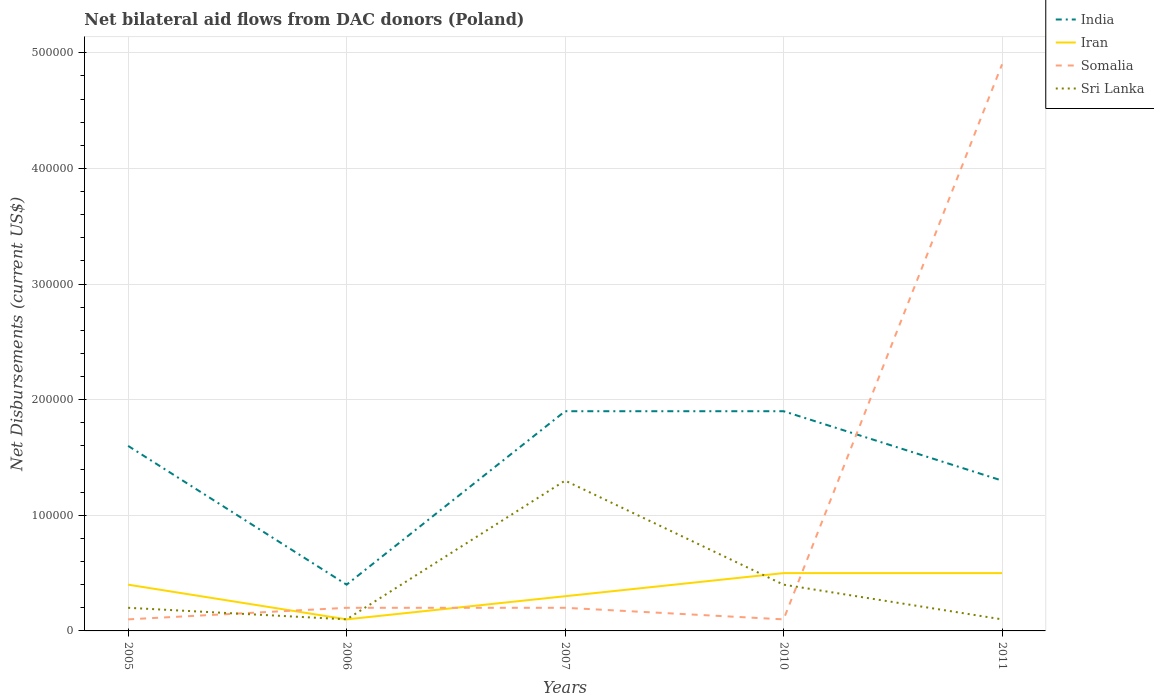How many different coloured lines are there?
Keep it short and to the point. 4. Does the line corresponding to Iran intersect with the line corresponding to India?
Keep it short and to the point. No. Is the number of lines equal to the number of legend labels?
Make the answer very short. Yes. Across all years, what is the maximum net bilateral aid flows in Sri Lanka?
Ensure brevity in your answer.  10000. What is the total net bilateral aid flows in India in the graph?
Give a very brief answer. 6.00e+04. What is the difference between the highest and the second highest net bilateral aid flows in India?
Give a very brief answer. 1.50e+05. What is the difference between the highest and the lowest net bilateral aid flows in Iran?
Give a very brief answer. 3. Where does the legend appear in the graph?
Keep it short and to the point. Top right. How are the legend labels stacked?
Provide a short and direct response. Vertical. What is the title of the graph?
Your response must be concise. Net bilateral aid flows from DAC donors (Poland). Does "Mauritania" appear as one of the legend labels in the graph?
Give a very brief answer. No. What is the label or title of the Y-axis?
Give a very brief answer. Net Disbursements (current US$). What is the Net Disbursements (current US$) of Iran in 2005?
Offer a very short reply. 4.00e+04. What is the Net Disbursements (current US$) of Somalia in 2005?
Offer a terse response. 10000. What is the Net Disbursements (current US$) in Sri Lanka in 2005?
Your answer should be compact. 2.00e+04. What is the Net Disbursements (current US$) in India in 2006?
Make the answer very short. 4.00e+04. What is the Net Disbursements (current US$) of Iran in 2006?
Your answer should be very brief. 10000. What is the Net Disbursements (current US$) in Sri Lanka in 2006?
Give a very brief answer. 10000. What is the Net Disbursements (current US$) of Iran in 2007?
Your answer should be compact. 3.00e+04. What is the Net Disbursements (current US$) in India in 2010?
Your answer should be compact. 1.90e+05. What is the Net Disbursements (current US$) of Somalia in 2010?
Make the answer very short. 10000. What is the Net Disbursements (current US$) of India in 2011?
Offer a very short reply. 1.30e+05. What is the Net Disbursements (current US$) of Somalia in 2011?
Your answer should be compact. 4.90e+05. What is the Net Disbursements (current US$) in Sri Lanka in 2011?
Make the answer very short. 10000. Across all years, what is the maximum Net Disbursements (current US$) in Iran?
Your answer should be very brief. 5.00e+04. Across all years, what is the maximum Net Disbursements (current US$) in Somalia?
Provide a short and direct response. 4.90e+05. Across all years, what is the maximum Net Disbursements (current US$) in Sri Lanka?
Keep it short and to the point. 1.30e+05. Across all years, what is the minimum Net Disbursements (current US$) of Somalia?
Offer a very short reply. 10000. Across all years, what is the minimum Net Disbursements (current US$) in Sri Lanka?
Provide a succinct answer. 10000. What is the total Net Disbursements (current US$) in India in the graph?
Ensure brevity in your answer.  7.10e+05. What is the total Net Disbursements (current US$) in Iran in the graph?
Provide a succinct answer. 1.80e+05. What is the total Net Disbursements (current US$) in Somalia in the graph?
Your answer should be very brief. 5.50e+05. What is the difference between the Net Disbursements (current US$) of Somalia in 2005 and that in 2006?
Your response must be concise. -10000. What is the difference between the Net Disbursements (current US$) in India in 2005 and that in 2007?
Keep it short and to the point. -3.00e+04. What is the difference between the Net Disbursements (current US$) in Somalia in 2005 and that in 2007?
Provide a short and direct response. -10000. What is the difference between the Net Disbursements (current US$) in Sri Lanka in 2005 and that in 2007?
Keep it short and to the point. -1.10e+05. What is the difference between the Net Disbursements (current US$) in India in 2005 and that in 2010?
Ensure brevity in your answer.  -3.00e+04. What is the difference between the Net Disbursements (current US$) of Sri Lanka in 2005 and that in 2010?
Ensure brevity in your answer.  -2.00e+04. What is the difference between the Net Disbursements (current US$) of India in 2005 and that in 2011?
Offer a very short reply. 3.00e+04. What is the difference between the Net Disbursements (current US$) of Iran in 2005 and that in 2011?
Make the answer very short. -10000. What is the difference between the Net Disbursements (current US$) of Somalia in 2005 and that in 2011?
Ensure brevity in your answer.  -4.80e+05. What is the difference between the Net Disbursements (current US$) of Sri Lanka in 2005 and that in 2011?
Your answer should be very brief. 10000. What is the difference between the Net Disbursements (current US$) in India in 2006 and that in 2007?
Your response must be concise. -1.50e+05. What is the difference between the Net Disbursements (current US$) of Sri Lanka in 2006 and that in 2007?
Your answer should be compact. -1.20e+05. What is the difference between the Net Disbursements (current US$) in India in 2006 and that in 2010?
Provide a short and direct response. -1.50e+05. What is the difference between the Net Disbursements (current US$) in Iran in 2006 and that in 2010?
Your answer should be compact. -4.00e+04. What is the difference between the Net Disbursements (current US$) of Somalia in 2006 and that in 2010?
Provide a succinct answer. 10000. What is the difference between the Net Disbursements (current US$) of India in 2006 and that in 2011?
Keep it short and to the point. -9.00e+04. What is the difference between the Net Disbursements (current US$) of Somalia in 2006 and that in 2011?
Offer a very short reply. -4.70e+05. What is the difference between the Net Disbursements (current US$) in India in 2007 and that in 2010?
Provide a succinct answer. 0. What is the difference between the Net Disbursements (current US$) in Iran in 2007 and that in 2010?
Keep it short and to the point. -2.00e+04. What is the difference between the Net Disbursements (current US$) in Somalia in 2007 and that in 2010?
Keep it short and to the point. 10000. What is the difference between the Net Disbursements (current US$) in Sri Lanka in 2007 and that in 2010?
Keep it short and to the point. 9.00e+04. What is the difference between the Net Disbursements (current US$) of India in 2007 and that in 2011?
Give a very brief answer. 6.00e+04. What is the difference between the Net Disbursements (current US$) in Iran in 2007 and that in 2011?
Offer a very short reply. -2.00e+04. What is the difference between the Net Disbursements (current US$) of Somalia in 2007 and that in 2011?
Provide a succinct answer. -4.70e+05. What is the difference between the Net Disbursements (current US$) of Somalia in 2010 and that in 2011?
Ensure brevity in your answer.  -4.80e+05. What is the difference between the Net Disbursements (current US$) of Sri Lanka in 2010 and that in 2011?
Provide a succinct answer. 3.00e+04. What is the difference between the Net Disbursements (current US$) in India in 2005 and the Net Disbursements (current US$) in Iran in 2006?
Provide a succinct answer. 1.50e+05. What is the difference between the Net Disbursements (current US$) in Iran in 2005 and the Net Disbursements (current US$) in Somalia in 2006?
Keep it short and to the point. 2.00e+04. What is the difference between the Net Disbursements (current US$) of India in 2005 and the Net Disbursements (current US$) of Iran in 2007?
Ensure brevity in your answer.  1.30e+05. What is the difference between the Net Disbursements (current US$) in Iran in 2005 and the Net Disbursements (current US$) in Somalia in 2007?
Ensure brevity in your answer.  2.00e+04. What is the difference between the Net Disbursements (current US$) in Iran in 2005 and the Net Disbursements (current US$) in Sri Lanka in 2007?
Provide a succinct answer. -9.00e+04. What is the difference between the Net Disbursements (current US$) in India in 2005 and the Net Disbursements (current US$) in Iran in 2010?
Give a very brief answer. 1.10e+05. What is the difference between the Net Disbursements (current US$) of India in 2005 and the Net Disbursements (current US$) of Sri Lanka in 2010?
Offer a terse response. 1.20e+05. What is the difference between the Net Disbursements (current US$) in Iran in 2005 and the Net Disbursements (current US$) in Sri Lanka in 2010?
Your answer should be very brief. 0. What is the difference between the Net Disbursements (current US$) of India in 2005 and the Net Disbursements (current US$) of Iran in 2011?
Provide a succinct answer. 1.10e+05. What is the difference between the Net Disbursements (current US$) of India in 2005 and the Net Disbursements (current US$) of Somalia in 2011?
Offer a very short reply. -3.30e+05. What is the difference between the Net Disbursements (current US$) in India in 2005 and the Net Disbursements (current US$) in Sri Lanka in 2011?
Make the answer very short. 1.50e+05. What is the difference between the Net Disbursements (current US$) of Iran in 2005 and the Net Disbursements (current US$) of Somalia in 2011?
Keep it short and to the point. -4.50e+05. What is the difference between the Net Disbursements (current US$) in India in 2006 and the Net Disbursements (current US$) in Iran in 2007?
Your response must be concise. 10000. What is the difference between the Net Disbursements (current US$) in India in 2006 and the Net Disbursements (current US$) in Somalia in 2007?
Offer a very short reply. 2.00e+04. What is the difference between the Net Disbursements (current US$) in India in 2006 and the Net Disbursements (current US$) in Sri Lanka in 2007?
Make the answer very short. -9.00e+04. What is the difference between the Net Disbursements (current US$) in Iran in 2006 and the Net Disbursements (current US$) in Sri Lanka in 2007?
Make the answer very short. -1.20e+05. What is the difference between the Net Disbursements (current US$) of Somalia in 2006 and the Net Disbursements (current US$) of Sri Lanka in 2007?
Provide a succinct answer. -1.10e+05. What is the difference between the Net Disbursements (current US$) in India in 2006 and the Net Disbursements (current US$) in Iran in 2010?
Offer a very short reply. -10000. What is the difference between the Net Disbursements (current US$) of India in 2006 and the Net Disbursements (current US$) of Somalia in 2010?
Offer a very short reply. 3.00e+04. What is the difference between the Net Disbursements (current US$) in India in 2006 and the Net Disbursements (current US$) in Sri Lanka in 2010?
Ensure brevity in your answer.  0. What is the difference between the Net Disbursements (current US$) of Iran in 2006 and the Net Disbursements (current US$) of Somalia in 2010?
Ensure brevity in your answer.  0. What is the difference between the Net Disbursements (current US$) of India in 2006 and the Net Disbursements (current US$) of Somalia in 2011?
Provide a succinct answer. -4.50e+05. What is the difference between the Net Disbursements (current US$) in India in 2006 and the Net Disbursements (current US$) in Sri Lanka in 2011?
Provide a succinct answer. 3.00e+04. What is the difference between the Net Disbursements (current US$) of Iran in 2006 and the Net Disbursements (current US$) of Somalia in 2011?
Your answer should be very brief. -4.80e+05. What is the difference between the Net Disbursements (current US$) in Iran in 2006 and the Net Disbursements (current US$) in Sri Lanka in 2011?
Give a very brief answer. 0. What is the difference between the Net Disbursements (current US$) of India in 2007 and the Net Disbursements (current US$) of Iran in 2010?
Keep it short and to the point. 1.40e+05. What is the difference between the Net Disbursements (current US$) in Iran in 2007 and the Net Disbursements (current US$) in Sri Lanka in 2010?
Your response must be concise. -10000. What is the difference between the Net Disbursements (current US$) of India in 2007 and the Net Disbursements (current US$) of Sri Lanka in 2011?
Give a very brief answer. 1.80e+05. What is the difference between the Net Disbursements (current US$) of Iran in 2007 and the Net Disbursements (current US$) of Somalia in 2011?
Provide a succinct answer. -4.60e+05. What is the difference between the Net Disbursements (current US$) in Somalia in 2007 and the Net Disbursements (current US$) in Sri Lanka in 2011?
Keep it short and to the point. 10000. What is the difference between the Net Disbursements (current US$) of Iran in 2010 and the Net Disbursements (current US$) of Somalia in 2011?
Make the answer very short. -4.40e+05. What is the difference between the Net Disbursements (current US$) of Iran in 2010 and the Net Disbursements (current US$) of Sri Lanka in 2011?
Your answer should be very brief. 4.00e+04. What is the difference between the Net Disbursements (current US$) in Somalia in 2010 and the Net Disbursements (current US$) in Sri Lanka in 2011?
Keep it short and to the point. 0. What is the average Net Disbursements (current US$) in India per year?
Provide a succinct answer. 1.42e+05. What is the average Net Disbursements (current US$) in Iran per year?
Make the answer very short. 3.60e+04. What is the average Net Disbursements (current US$) of Somalia per year?
Provide a succinct answer. 1.10e+05. What is the average Net Disbursements (current US$) in Sri Lanka per year?
Make the answer very short. 4.20e+04. In the year 2005, what is the difference between the Net Disbursements (current US$) in India and Net Disbursements (current US$) in Somalia?
Your response must be concise. 1.50e+05. In the year 2005, what is the difference between the Net Disbursements (current US$) of Iran and Net Disbursements (current US$) of Sri Lanka?
Your answer should be very brief. 2.00e+04. In the year 2006, what is the difference between the Net Disbursements (current US$) of India and Net Disbursements (current US$) of Iran?
Your response must be concise. 3.00e+04. In the year 2006, what is the difference between the Net Disbursements (current US$) of India and Net Disbursements (current US$) of Somalia?
Your answer should be very brief. 2.00e+04. In the year 2006, what is the difference between the Net Disbursements (current US$) in India and Net Disbursements (current US$) in Sri Lanka?
Provide a short and direct response. 3.00e+04. In the year 2006, what is the difference between the Net Disbursements (current US$) of Iran and Net Disbursements (current US$) of Somalia?
Provide a short and direct response. -10000. In the year 2006, what is the difference between the Net Disbursements (current US$) of Somalia and Net Disbursements (current US$) of Sri Lanka?
Provide a succinct answer. 10000. In the year 2007, what is the difference between the Net Disbursements (current US$) in India and Net Disbursements (current US$) in Somalia?
Give a very brief answer. 1.70e+05. In the year 2007, what is the difference between the Net Disbursements (current US$) of India and Net Disbursements (current US$) of Sri Lanka?
Offer a very short reply. 6.00e+04. In the year 2007, what is the difference between the Net Disbursements (current US$) of Iran and Net Disbursements (current US$) of Sri Lanka?
Give a very brief answer. -1.00e+05. In the year 2010, what is the difference between the Net Disbursements (current US$) in India and Net Disbursements (current US$) in Iran?
Your response must be concise. 1.40e+05. In the year 2010, what is the difference between the Net Disbursements (current US$) of India and Net Disbursements (current US$) of Somalia?
Give a very brief answer. 1.80e+05. In the year 2010, what is the difference between the Net Disbursements (current US$) of Iran and Net Disbursements (current US$) of Sri Lanka?
Ensure brevity in your answer.  10000. In the year 2010, what is the difference between the Net Disbursements (current US$) in Somalia and Net Disbursements (current US$) in Sri Lanka?
Provide a short and direct response. -3.00e+04. In the year 2011, what is the difference between the Net Disbursements (current US$) of India and Net Disbursements (current US$) of Iran?
Make the answer very short. 8.00e+04. In the year 2011, what is the difference between the Net Disbursements (current US$) in India and Net Disbursements (current US$) in Somalia?
Provide a short and direct response. -3.60e+05. In the year 2011, what is the difference between the Net Disbursements (current US$) in India and Net Disbursements (current US$) in Sri Lanka?
Make the answer very short. 1.20e+05. In the year 2011, what is the difference between the Net Disbursements (current US$) of Iran and Net Disbursements (current US$) of Somalia?
Give a very brief answer. -4.40e+05. In the year 2011, what is the difference between the Net Disbursements (current US$) in Iran and Net Disbursements (current US$) in Sri Lanka?
Offer a very short reply. 4.00e+04. What is the ratio of the Net Disbursements (current US$) in India in 2005 to that in 2006?
Give a very brief answer. 4. What is the ratio of the Net Disbursements (current US$) in Somalia in 2005 to that in 2006?
Your answer should be compact. 0.5. What is the ratio of the Net Disbursements (current US$) of Sri Lanka in 2005 to that in 2006?
Provide a succinct answer. 2. What is the ratio of the Net Disbursements (current US$) of India in 2005 to that in 2007?
Offer a very short reply. 0.84. What is the ratio of the Net Disbursements (current US$) of Iran in 2005 to that in 2007?
Give a very brief answer. 1.33. What is the ratio of the Net Disbursements (current US$) in Somalia in 2005 to that in 2007?
Ensure brevity in your answer.  0.5. What is the ratio of the Net Disbursements (current US$) in Sri Lanka in 2005 to that in 2007?
Offer a very short reply. 0.15. What is the ratio of the Net Disbursements (current US$) of India in 2005 to that in 2010?
Offer a very short reply. 0.84. What is the ratio of the Net Disbursements (current US$) of Iran in 2005 to that in 2010?
Give a very brief answer. 0.8. What is the ratio of the Net Disbursements (current US$) of Somalia in 2005 to that in 2010?
Offer a terse response. 1. What is the ratio of the Net Disbursements (current US$) of India in 2005 to that in 2011?
Keep it short and to the point. 1.23. What is the ratio of the Net Disbursements (current US$) in Iran in 2005 to that in 2011?
Your response must be concise. 0.8. What is the ratio of the Net Disbursements (current US$) in Somalia in 2005 to that in 2011?
Make the answer very short. 0.02. What is the ratio of the Net Disbursements (current US$) in India in 2006 to that in 2007?
Offer a very short reply. 0.21. What is the ratio of the Net Disbursements (current US$) in Iran in 2006 to that in 2007?
Keep it short and to the point. 0.33. What is the ratio of the Net Disbursements (current US$) in Sri Lanka in 2006 to that in 2007?
Ensure brevity in your answer.  0.08. What is the ratio of the Net Disbursements (current US$) of India in 2006 to that in 2010?
Provide a succinct answer. 0.21. What is the ratio of the Net Disbursements (current US$) of Somalia in 2006 to that in 2010?
Provide a short and direct response. 2. What is the ratio of the Net Disbursements (current US$) in Sri Lanka in 2006 to that in 2010?
Offer a terse response. 0.25. What is the ratio of the Net Disbursements (current US$) of India in 2006 to that in 2011?
Make the answer very short. 0.31. What is the ratio of the Net Disbursements (current US$) in Somalia in 2006 to that in 2011?
Make the answer very short. 0.04. What is the ratio of the Net Disbursements (current US$) of Somalia in 2007 to that in 2010?
Your answer should be compact. 2. What is the ratio of the Net Disbursements (current US$) in Sri Lanka in 2007 to that in 2010?
Give a very brief answer. 3.25. What is the ratio of the Net Disbursements (current US$) in India in 2007 to that in 2011?
Provide a short and direct response. 1.46. What is the ratio of the Net Disbursements (current US$) of Somalia in 2007 to that in 2011?
Provide a succinct answer. 0.04. What is the ratio of the Net Disbursements (current US$) of India in 2010 to that in 2011?
Offer a very short reply. 1.46. What is the ratio of the Net Disbursements (current US$) in Iran in 2010 to that in 2011?
Your answer should be very brief. 1. What is the ratio of the Net Disbursements (current US$) in Somalia in 2010 to that in 2011?
Keep it short and to the point. 0.02. What is the difference between the highest and the second highest Net Disbursements (current US$) in India?
Keep it short and to the point. 0. What is the difference between the highest and the second highest Net Disbursements (current US$) of Somalia?
Provide a short and direct response. 4.70e+05. What is the difference between the highest and the lowest Net Disbursements (current US$) in India?
Ensure brevity in your answer.  1.50e+05. What is the difference between the highest and the lowest Net Disbursements (current US$) in Somalia?
Offer a terse response. 4.80e+05. 